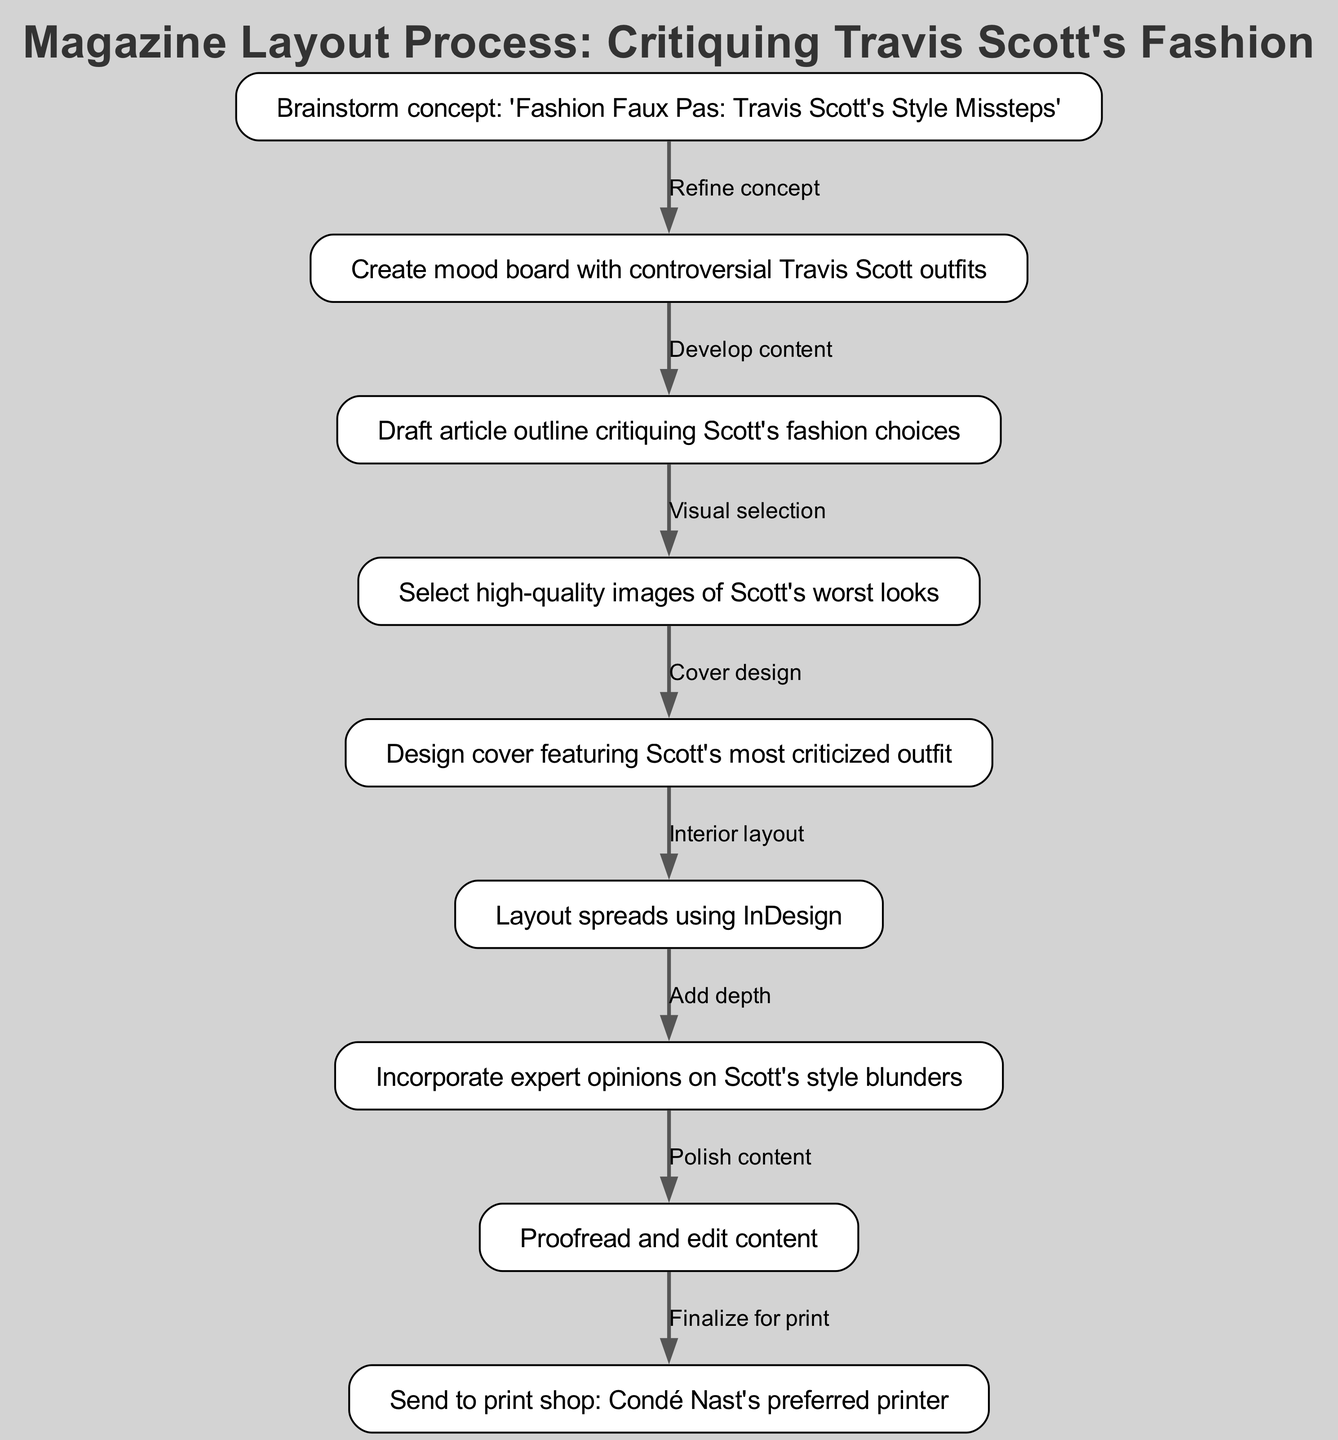What is the starting concept of the magazine layout process? The first node in the diagram clearly states the starting concept: “Brainstorm concept: 'Fashion Faux Pas: Travis Scott's Style Missteps'.” Thus, this is the initial idea from which all other steps proceed.
Answer: Brainstorm concept: 'Fashion Faux Pas: Travis Scott's Style Missteps' How many nodes are in the diagram? By counting the individual nodes present in the diagram, we find that there are 9 distinct steps. Each node corresponds to a specific action or idea in the layout process.
Answer: 9 Which two nodes represent the beginning and the end of the process? The first node “Brainstorm concept: 'Fashion Faux Pas: Travis Scott's Style Missteps'” marks the beginning, and the last node “Send to print shop: Condé Nast's preferred printer” marks the end. These establish the process flow from concept to print.
Answer: Brainstorm concept: 'Fashion Faux Pas: Travis Scott's Style Missteps' and Send to print shop: Condé Nast's preferred printer What action follows the mood board creation? The second node states: “Create mood board with controversial Travis Scott outfits”, and the edge advises that the next action is “Draft article outline critiquing Scott's fashion choices,” indicating a sequential flow of actions that follow the visual selection process.
Answer: Draft article outline critiquing Scott's fashion choices Which node focuses on editing the content? The node that pertains to content editing is “Proofread and edit content.” It signifies a crucial step before the final print stage, ensuring that all content is polished and free from errors.
Answer: Proofread and edit content What is the relationship between selecting images and cover design? The diagram indicates a direct flow from the node “Select high-quality images of Scott's worst looks” to the node “Design cover featuring Scott's most criticized outfit,” highlighting the visual coherence needed for an impactful cover.
Answer: Cover design Which step adds depth to the magazine layout? The node identified as "Incorporate expert opinions on Scott's style blunders" emphasizes a significant layer of depth to the magazine's content. This inclusion of expert opinions aims to enhance the credibility and richness of the critique.
Answer: Incorporate expert opinions on Scott's style blunders What is the main purpose of the mood board in this process? The mood board serves the purpose of capturing the essence of “controversial Travis Scott outfits,” which aids in visually guiding the overall layout and feel of the magazine before detailed content creation.
Answer: Controversial Travis Scott outfits 